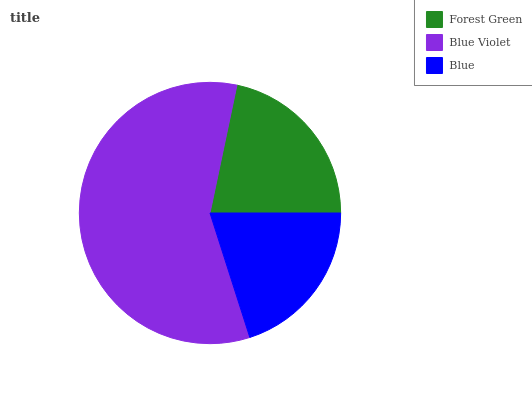Is Blue the minimum?
Answer yes or no. Yes. Is Blue Violet the maximum?
Answer yes or no. Yes. Is Blue Violet the minimum?
Answer yes or no. No. Is Blue the maximum?
Answer yes or no. No. Is Blue Violet greater than Blue?
Answer yes or no. Yes. Is Blue less than Blue Violet?
Answer yes or no. Yes. Is Blue greater than Blue Violet?
Answer yes or no. No. Is Blue Violet less than Blue?
Answer yes or no. No. Is Forest Green the high median?
Answer yes or no. Yes. Is Forest Green the low median?
Answer yes or no. Yes. Is Blue Violet the high median?
Answer yes or no. No. Is Blue Violet the low median?
Answer yes or no. No. 